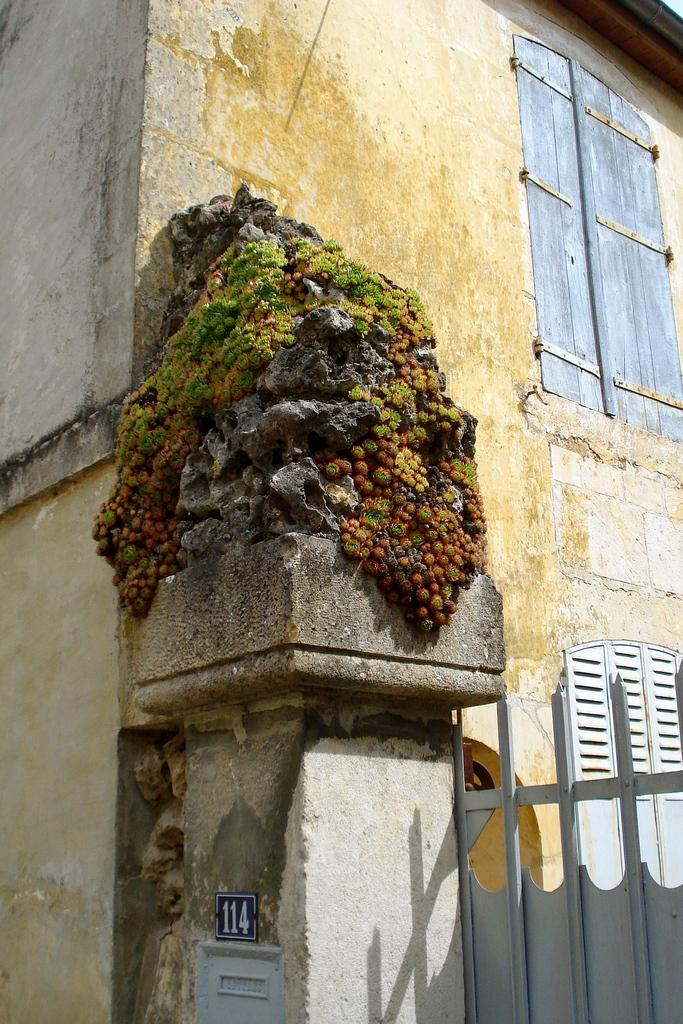What type of structure can be seen in the image? There is a metal gate in the image. What is attached to a pillar of a building in the image? There is a number plate on a pillar of a building in the image. What is the condition of the window at the top of the building in the image? The window at the top of the building is closed. What type of pain is the minister experiencing in the image? There is no minister or any indication of pain present in the image. How many pears are visible on the metal gate in the image? There are no pears present in the image; it features a metal gate and a number plate on a building. 